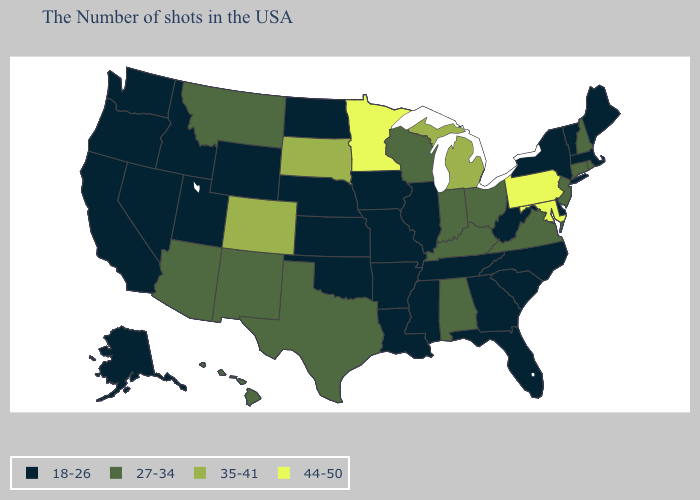What is the highest value in the USA?
Short answer required. 44-50. What is the lowest value in states that border Kansas?
Answer briefly. 18-26. What is the lowest value in the Northeast?
Write a very short answer. 18-26. Is the legend a continuous bar?
Give a very brief answer. No. What is the value of Colorado?
Give a very brief answer. 35-41. Does Kentucky have a higher value than Rhode Island?
Concise answer only. No. Among the states that border Pennsylvania , which have the lowest value?
Be succinct. New York, Delaware, West Virginia. Does Virginia have a lower value than Florida?
Be succinct. No. What is the highest value in the USA?
Answer briefly. 44-50. Which states have the lowest value in the USA?
Quick response, please. Maine, Massachusetts, Vermont, New York, Delaware, North Carolina, South Carolina, West Virginia, Florida, Georgia, Tennessee, Illinois, Mississippi, Louisiana, Missouri, Arkansas, Iowa, Kansas, Nebraska, Oklahoma, North Dakota, Wyoming, Utah, Idaho, Nevada, California, Washington, Oregon, Alaska. Does Pennsylvania have the highest value in the Northeast?
Keep it brief. Yes. Name the states that have a value in the range 35-41?
Short answer required. Michigan, South Dakota, Colorado. Which states hav the highest value in the West?
Concise answer only. Colorado. Among the states that border New Jersey , does Pennsylvania have the lowest value?
Keep it brief. No. Which states hav the highest value in the West?
Concise answer only. Colorado. 